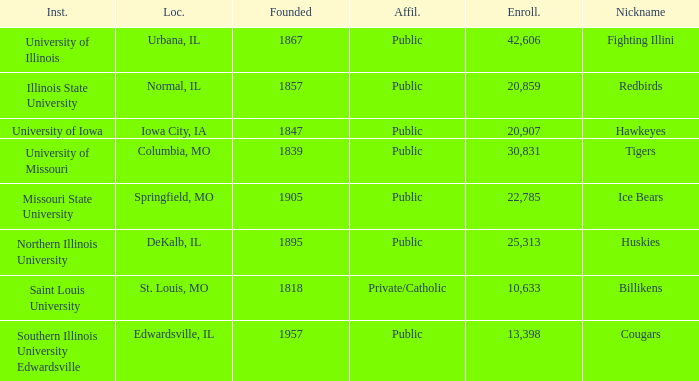What is the average enrollment of the Redbirds' school? 20859.0. 